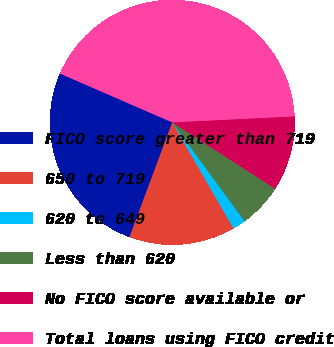Convert chart. <chart><loc_0><loc_0><loc_500><loc_500><pie_chart><fcel>FICO score greater than 719<fcel>650 to 719<fcel>620 to 649<fcel>Less than 620<fcel>No FICO score available or<fcel>Total loans using FICO credit<nl><fcel>25.85%<fcel>14.01%<fcel>1.72%<fcel>5.82%<fcel>9.91%<fcel>42.68%<nl></chart> 